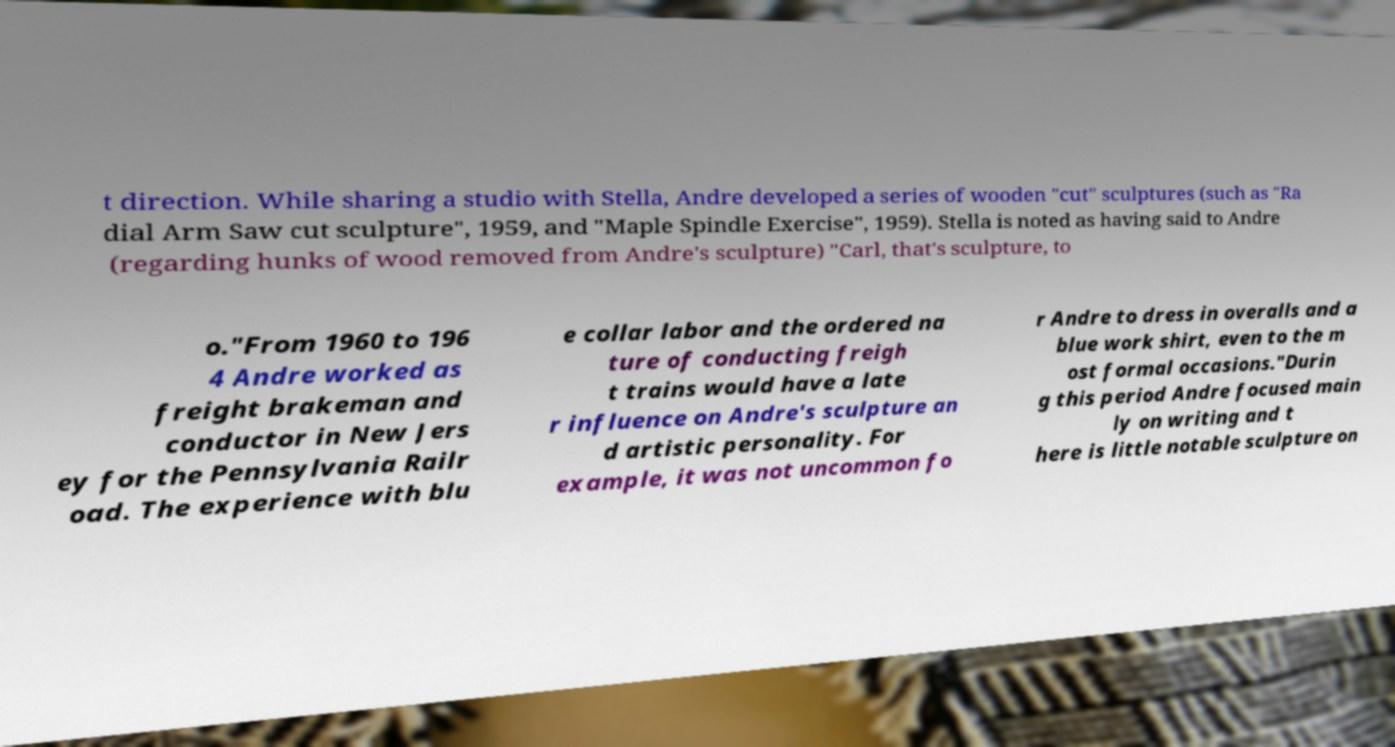Please identify and transcribe the text found in this image. t direction. While sharing a studio with Stella, Andre developed a series of wooden "cut" sculptures (such as "Ra dial Arm Saw cut sculpture", 1959, and "Maple Spindle Exercise", 1959). Stella is noted as having said to Andre (regarding hunks of wood removed from Andre's sculpture) "Carl, that's sculpture, to o."From 1960 to 196 4 Andre worked as freight brakeman and conductor in New Jers ey for the Pennsylvania Railr oad. The experience with blu e collar labor and the ordered na ture of conducting freigh t trains would have a late r influence on Andre's sculpture an d artistic personality. For example, it was not uncommon fo r Andre to dress in overalls and a blue work shirt, even to the m ost formal occasions."Durin g this period Andre focused main ly on writing and t here is little notable sculpture on 